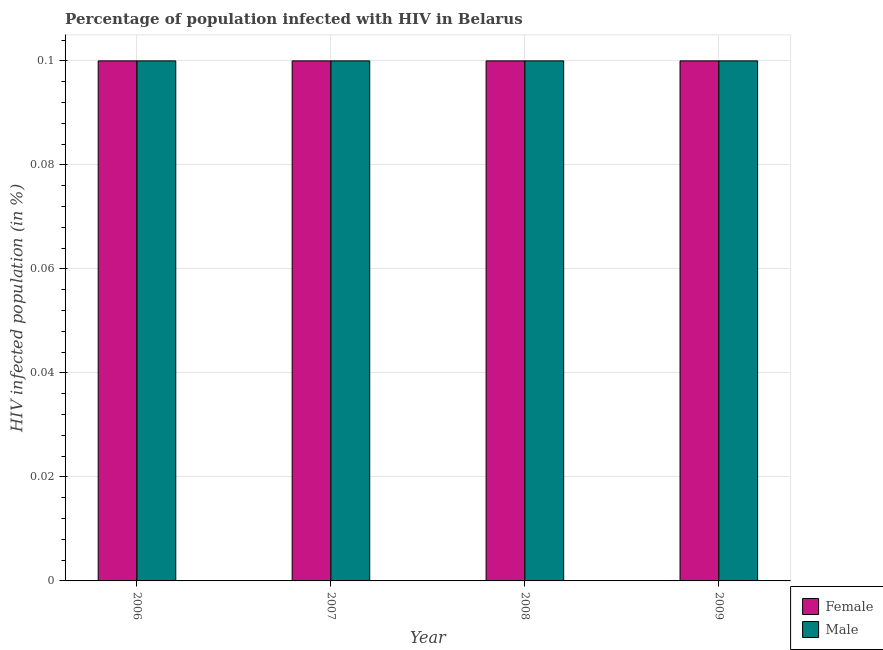Are the number of bars on each tick of the X-axis equal?
Your response must be concise. Yes. How many bars are there on the 1st tick from the right?
Your response must be concise. 2. In which year was the percentage of females who are infected with hiv minimum?
Your response must be concise. 2006. In the year 2007, what is the difference between the percentage of males who are infected with hiv and percentage of females who are infected with hiv?
Your response must be concise. 0. Is the percentage of females who are infected with hiv in 2006 less than that in 2007?
Offer a very short reply. No. What is the difference between the highest and the second highest percentage of males who are infected with hiv?
Your response must be concise. 0. In how many years, is the percentage of males who are infected with hiv greater than the average percentage of males who are infected with hiv taken over all years?
Offer a very short reply. 0. What does the 2nd bar from the left in 2007 represents?
Your response must be concise. Male. What does the 1st bar from the right in 2009 represents?
Keep it short and to the point. Male. Are all the bars in the graph horizontal?
Ensure brevity in your answer.  No. How many years are there in the graph?
Offer a very short reply. 4. What is the difference between two consecutive major ticks on the Y-axis?
Make the answer very short. 0.02. Are the values on the major ticks of Y-axis written in scientific E-notation?
Keep it short and to the point. No. Where does the legend appear in the graph?
Keep it short and to the point. Bottom right. What is the title of the graph?
Give a very brief answer. Percentage of population infected with HIV in Belarus. What is the label or title of the X-axis?
Your answer should be very brief. Year. What is the label or title of the Y-axis?
Your response must be concise. HIV infected population (in %). What is the HIV infected population (in %) of Male in 2006?
Provide a short and direct response. 0.1. What is the HIV infected population (in %) in Female in 2007?
Offer a terse response. 0.1. What is the HIV infected population (in %) in Female in 2008?
Keep it short and to the point. 0.1. What is the HIV infected population (in %) of Female in 2009?
Offer a very short reply. 0.1. Across all years, what is the minimum HIV infected population (in %) of Female?
Make the answer very short. 0.1. Across all years, what is the minimum HIV infected population (in %) in Male?
Provide a short and direct response. 0.1. What is the total HIV infected population (in %) in Female in the graph?
Make the answer very short. 0.4. What is the total HIV infected population (in %) in Male in the graph?
Your answer should be very brief. 0.4. What is the difference between the HIV infected population (in %) in Male in 2006 and that in 2007?
Keep it short and to the point. 0. What is the difference between the HIV infected population (in %) in Female in 2006 and that in 2008?
Your response must be concise. 0. What is the difference between the HIV infected population (in %) in Female in 2006 and that in 2009?
Your answer should be very brief. 0. What is the difference between the HIV infected population (in %) in Male in 2006 and that in 2009?
Make the answer very short. 0. What is the difference between the HIV infected population (in %) of Male in 2007 and that in 2008?
Offer a very short reply. 0. What is the difference between the HIV infected population (in %) in Female in 2007 and that in 2009?
Your answer should be compact. 0. What is the difference between the HIV infected population (in %) of Male in 2007 and that in 2009?
Keep it short and to the point. 0. What is the difference between the HIV infected population (in %) in Female in 2006 and the HIV infected population (in %) in Male in 2007?
Provide a succinct answer. 0. What is the difference between the HIV infected population (in %) of Female in 2006 and the HIV infected population (in %) of Male in 2008?
Your response must be concise. 0. What is the difference between the HIV infected population (in %) in Female in 2006 and the HIV infected population (in %) in Male in 2009?
Make the answer very short. 0. What is the difference between the HIV infected population (in %) in Female in 2007 and the HIV infected population (in %) in Male in 2009?
Ensure brevity in your answer.  0. What is the difference between the HIV infected population (in %) in Female in 2008 and the HIV infected population (in %) in Male in 2009?
Offer a terse response. 0. In the year 2006, what is the difference between the HIV infected population (in %) in Female and HIV infected population (in %) in Male?
Give a very brief answer. 0. In the year 2008, what is the difference between the HIV infected population (in %) in Female and HIV infected population (in %) in Male?
Offer a terse response. 0. What is the ratio of the HIV infected population (in %) in Female in 2006 to that in 2007?
Your answer should be very brief. 1. What is the ratio of the HIV infected population (in %) of Male in 2006 to that in 2008?
Offer a very short reply. 1. What is the ratio of the HIV infected population (in %) of Female in 2006 to that in 2009?
Provide a succinct answer. 1. What is the ratio of the HIV infected population (in %) in Male in 2007 to that in 2008?
Ensure brevity in your answer.  1. What is the ratio of the HIV infected population (in %) of Male in 2007 to that in 2009?
Give a very brief answer. 1. What is the ratio of the HIV infected population (in %) of Male in 2008 to that in 2009?
Ensure brevity in your answer.  1. What is the difference between the highest and the second highest HIV infected population (in %) of Female?
Offer a very short reply. 0. What is the difference between the highest and the lowest HIV infected population (in %) of Female?
Make the answer very short. 0. 